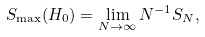Convert formula to latex. <formula><loc_0><loc_0><loc_500><loc_500>S _ { \max } ( H _ { 0 } ) = \lim _ { N \rightarrow \infty } N ^ { - 1 } S _ { N } ,</formula> 